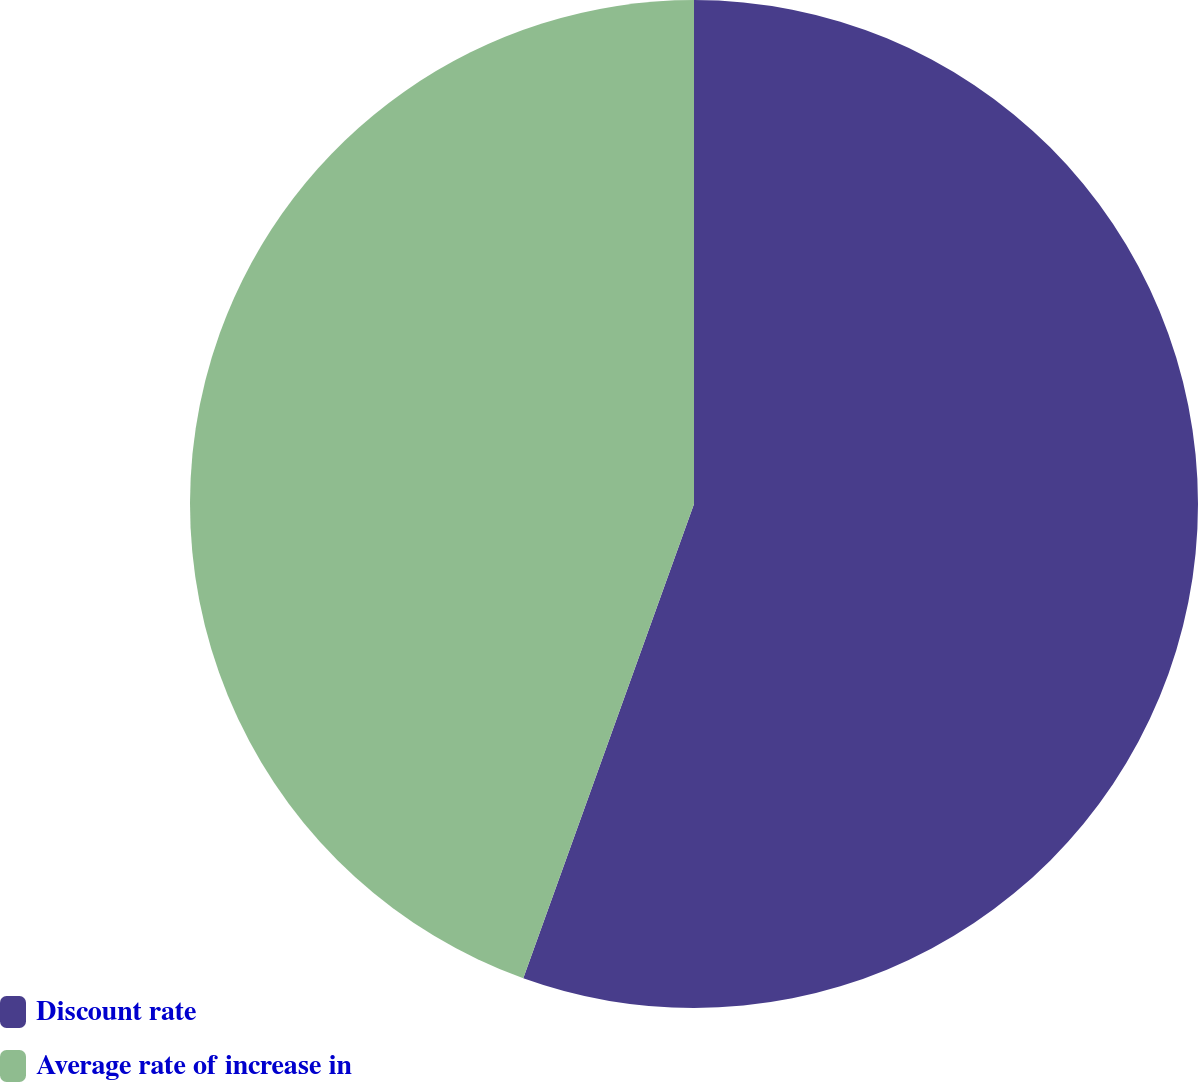Convert chart. <chart><loc_0><loc_0><loc_500><loc_500><pie_chart><fcel>Discount rate<fcel>Average rate of increase in<nl><fcel>55.5%<fcel>44.5%<nl></chart> 